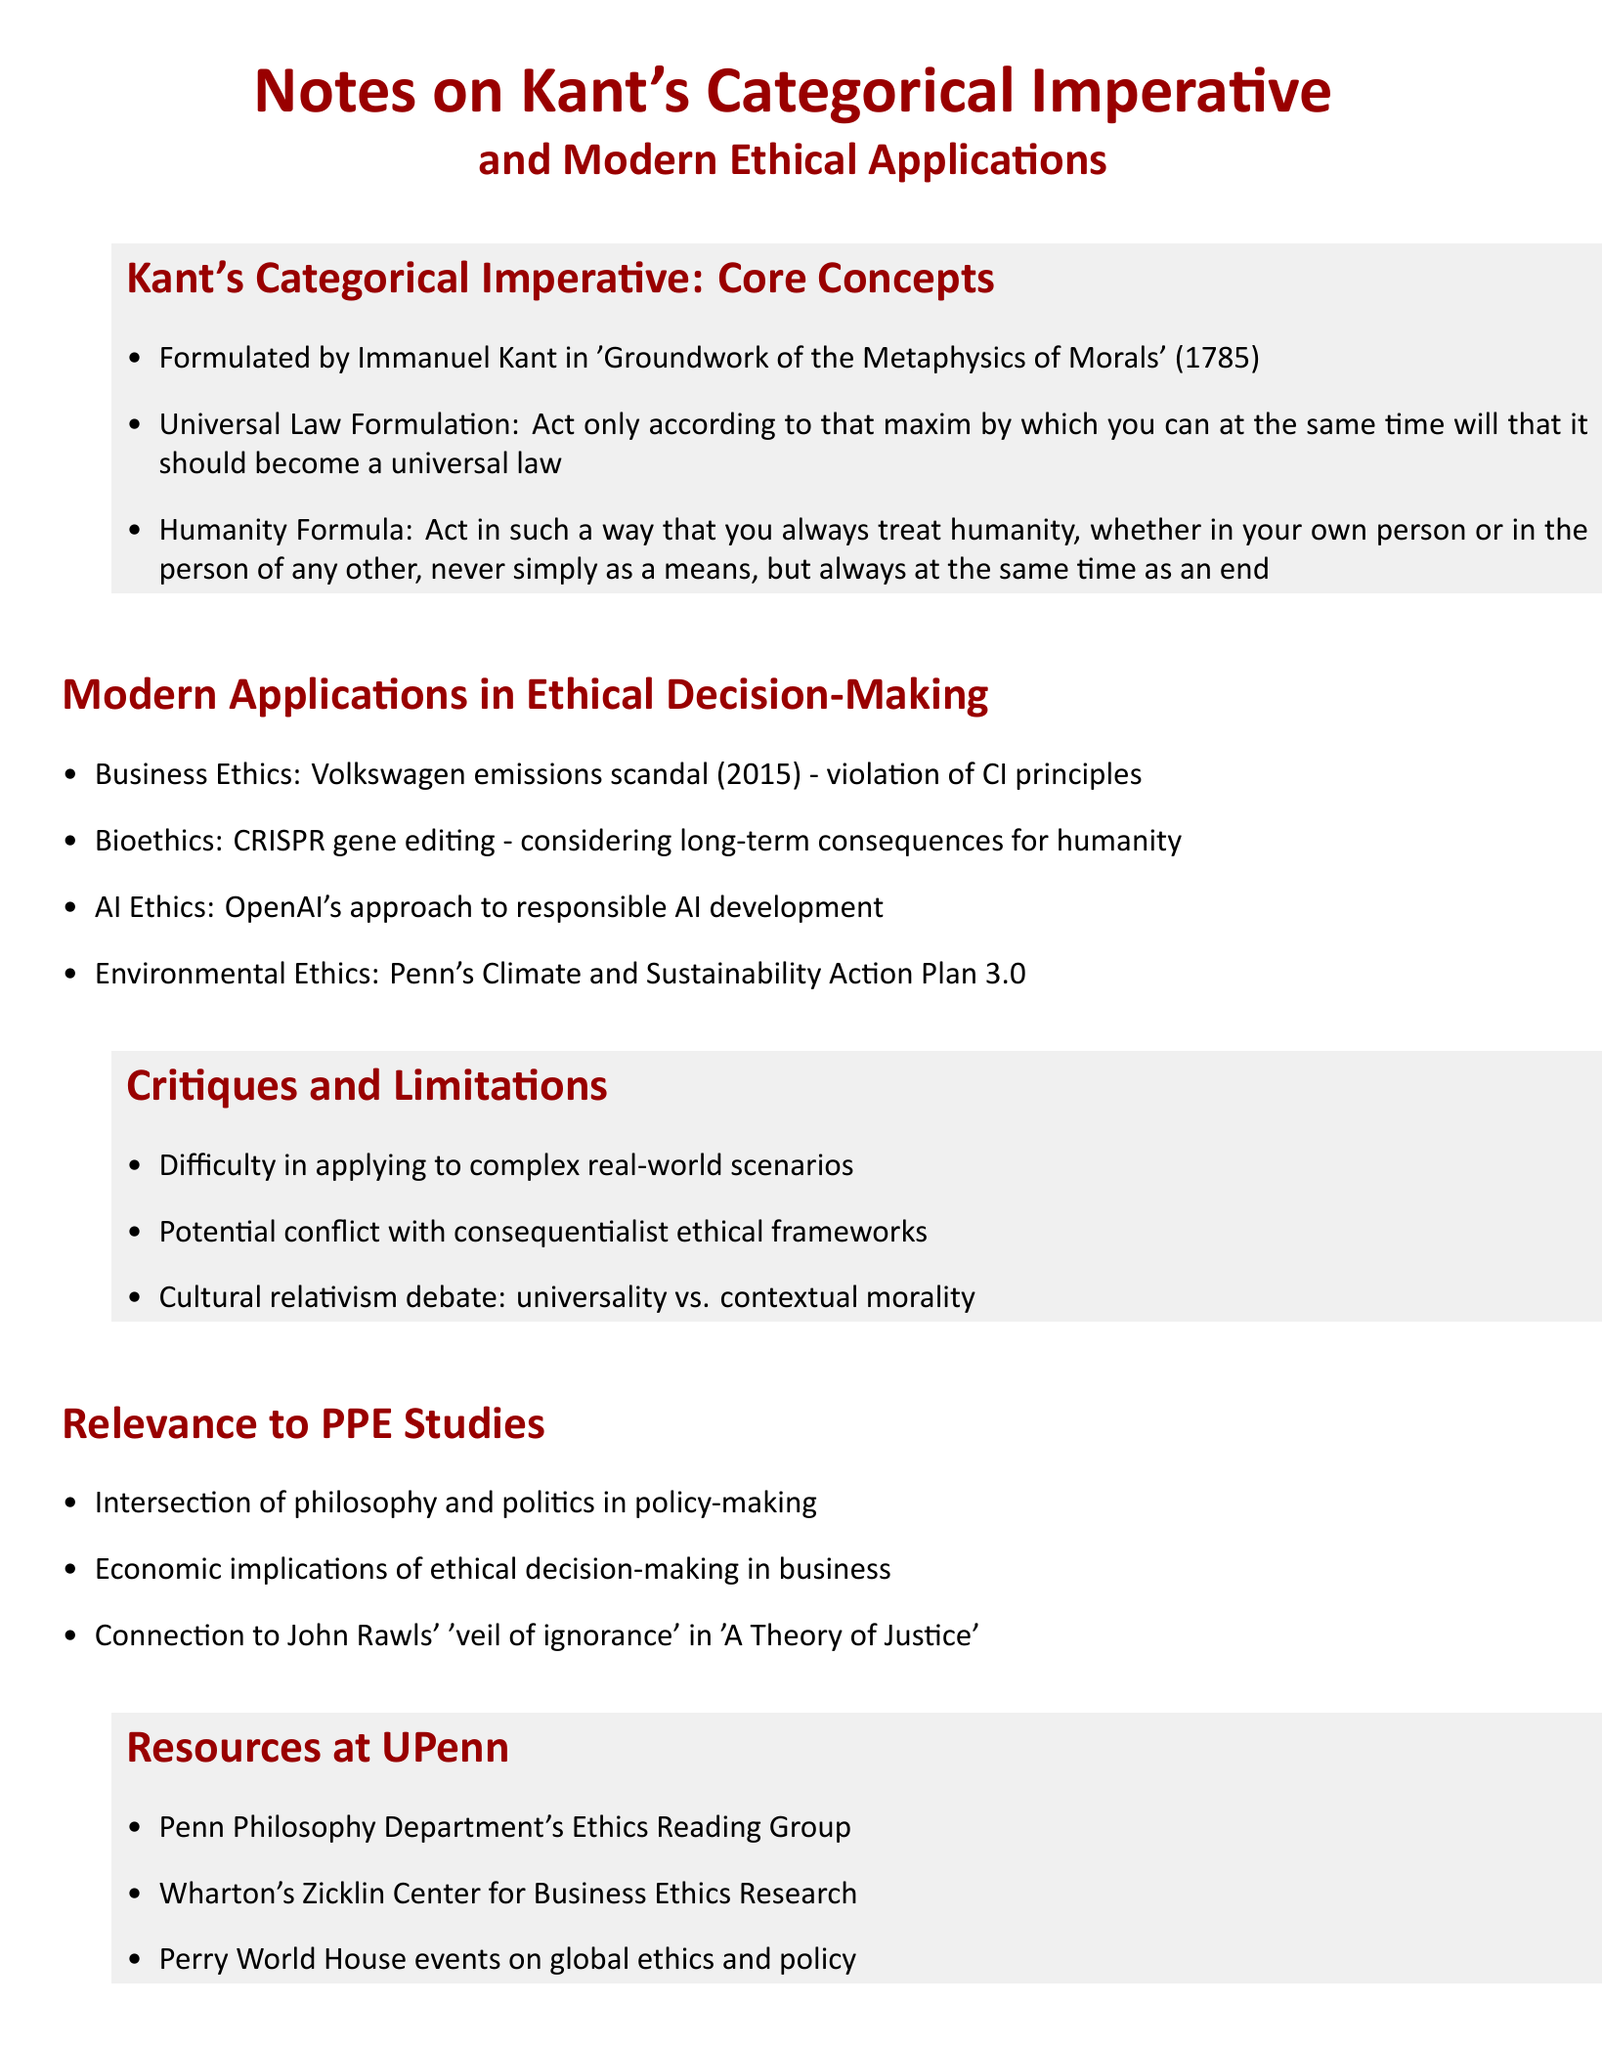What year was the Categorical Imperative formulated? The year when Kant formulated the Categorical Imperative is explicitly mentioned in the document.
Answer: 1785 What is the Business Ethics example mentioned in the document? The document refers to a specific business scandal as an example under Business Ethics.
Answer: Volkswagen emissions scandal Which ethical consideration is associated with CRISPR gene editing? The document discusses a modern application regarding the long-term impact in the context of bioethics.
Answer: Long-term consequences for humanity What framework is discussed in relation to critiques of Kant's Categorical Imperative? The document mentions a specific ethical framework that may conflict with Kant's philosophy.
Answer: Consequentialist ethical frameworks What is one resource mentioned at UPenn related to global ethics? The document lists a specific event series at UPenn that focuses on ethics and policy.
Answer: Perry World House events 